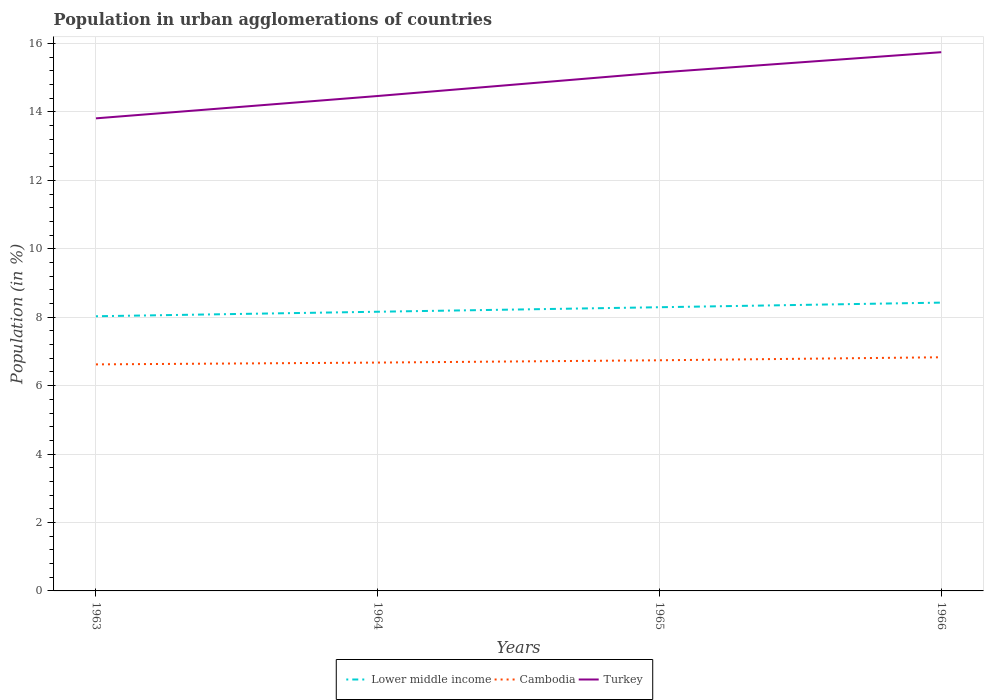How many different coloured lines are there?
Your response must be concise. 3. Is the number of lines equal to the number of legend labels?
Give a very brief answer. Yes. Across all years, what is the maximum percentage of population in urban agglomerations in Cambodia?
Your answer should be compact. 6.62. What is the total percentage of population in urban agglomerations in Turkey in the graph?
Your answer should be compact. -1.34. What is the difference between the highest and the second highest percentage of population in urban agglomerations in Cambodia?
Offer a terse response. 0.21. What is the difference between the highest and the lowest percentage of population in urban agglomerations in Turkey?
Make the answer very short. 2. Is the percentage of population in urban agglomerations in Lower middle income strictly greater than the percentage of population in urban agglomerations in Turkey over the years?
Ensure brevity in your answer.  Yes. Are the values on the major ticks of Y-axis written in scientific E-notation?
Make the answer very short. No. How many legend labels are there?
Your answer should be very brief. 3. What is the title of the graph?
Your answer should be compact. Population in urban agglomerations of countries. What is the label or title of the X-axis?
Keep it short and to the point. Years. What is the Population (in %) of Lower middle income in 1963?
Provide a short and direct response. 8.03. What is the Population (in %) in Cambodia in 1963?
Your answer should be very brief. 6.62. What is the Population (in %) of Turkey in 1963?
Your answer should be very brief. 13.81. What is the Population (in %) in Lower middle income in 1964?
Your response must be concise. 8.16. What is the Population (in %) in Cambodia in 1964?
Provide a short and direct response. 6.67. What is the Population (in %) in Turkey in 1964?
Keep it short and to the point. 14.47. What is the Population (in %) in Lower middle income in 1965?
Your answer should be very brief. 8.29. What is the Population (in %) in Cambodia in 1965?
Ensure brevity in your answer.  6.74. What is the Population (in %) of Turkey in 1965?
Provide a short and direct response. 15.15. What is the Population (in %) of Lower middle income in 1966?
Your answer should be compact. 8.43. What is the Population (in %) of Cambodia in 1966?
Offer a very short reply. 6.83. What is the Population (in %) in Turkey in 1966?
Provide a short and direct response. 15.75. Across all years, what is the maximum Population (in %) in Lower middle income?
Your response must be concise. 8.43. Across all years, what is the maximum Population (in %) in Cambodia?
Ensure brevity in your answer.  6.83. Across all years, what is the maximum Population (in %) in Turkey?
Provide a short and direct response. 15.75. Across all years, what is the minimum Population (in %) of Lower middle income?
Make the answer very short. 8.03. Across all years, what is the minimum Population (in %) in Cambodia?
Provide a succinct answer. 6.62. Across all years, what is the minimum Population (in %) in Turkey?
Ensure brevity in your answer.  13.81. What is the total Population (in %) of Lower middle income in the graph?
Your response must be concise. 32.91. What is the total Population (in %) in Cambodia in the graph?
Provide a succinct answer. 26.87. What is the total Population (in %) in Turkey in the graph?
Offer a very short reply. 59.18. What is the difference between the Population (in %) in Lower middle income in 1963 and that in 1964?
Give a very brief answer. -0.13. What is the difference between the Population (in %) in Cambodia in 1963 and that in 1964?
Keep it short and to the point. -0.05. What is the difference between the Population (in %) in Turkey in 1963 and that in 1964?
Offer a terse response. -0.65. What is the difference between the Population (in %) in Lower middle income in 1963 and that in 1965?
Offer a terse response. -0.26. What is the difference between the Population (in %) in Cambodia in 1963 and that in 1965?
Offer a very short reply. -0.12. What is the difference between the Population (in %) of Turkey in 1963 and that in 1965?
Offer a terse response. -1.34. What is the difference between the Population (in %) in Lower middle income in 1963 and that in 1966?
Offer a very short reply. -0.4. What is the difference between the Population (in %) of Cambodia in 1963 and that in 1966?
Your answer should be compact. -0.21. What is the difference between the Population (in %) of Turkey in 1963 and that in 1966?
Your response must be concise. -1.93. What is the difference between the Population (in %) of Lower middle income in 1964 and that in 1965?
Your answer should be compact. -0.13. What is the difference between the Population (in %) in Cambodia in 1964 and that in 1965?
Offer a very short reply. -0.07. What is the difference between the Population (in %) of Turkey in 1964 and that in 1965?
Offer a terse response. -0.69. What is the difference between the Population (in %) in Lower middle income in 1964 and that in 1966?
Give a very brief answer. -0.27. What is the difference between the Population (in %) of Cambodia in 1964 and that in 1966?
Provide a succinct answer. -0.16. What is the difference between the Population (in %) in Turkey in 1964 and that in 1966?
Give a very brief answer. -1.28. What is the difference between the Population (in %) in Lower middle income in 1965 and that in 1966?
Give a very brief answer. -0.13. What is the difference between the Population (in %) of Cambodia in 1965 and that in 1966?
Provide a short and direct response. -0.09. What is the difference between the Population (in %) of Turkey in 1965 and that in 1966?
Provide a short and direct response. -0.59. What is the difference between the Population (in %) in Lower middle income in 1963 and the Population (in %) in Cambodia in 1964?
Provide a succinct answer. 1.35. What is the difference between the Population (in %) in Lower middle income in 1963 and the Population (in %) in Turkey in 1964?
Offer a terse response. -6.44. What is the difference between the Population (in %) of Cambodia in 1963 and the Population (in %) of Turkey in 1964?
Offer a very short reply. -7.84. What is the difference between the Population (in %) in Lower middle income in 1963 and the Population (in %) in Cambodia in 1965?
Offer a terse response. 1.29. What is the difference between the Population (in %) of Lower middle income in 1963 and the Population (in %) of Turkey in 1965?
Ensure brevity in your answer.  -7.12. What is the difference between the Population (in %) of Cambodia in 1963 and the Population (in %) of Turkey in 1965?
Offer a terse response. -8.53. What is the difference between the Population (in %) of Lower middle income in 1963 and the Population (in %) of Cambodia in 1966?
Your response must be concise. 1.2. What is the difference between the Population (in %) in Lower middle income in 1963 and the Population (in %) in Turkey in 1966?
Offer a very short reply. -7.72. What is the difference between the Population (in %) in Cambodia in 1963 and the Population (in %) in Turkey in 1966?
Offer a very short reply. -9.13. What is the difference between the Population (in %) of Lower middle income in 1964 and the Population (in %) of Cambodia in 1965?
Make the answer very short. 1.42. What is the difference between the Population (in %) in Lower middle income in 1964 and the Population (in %) in Turkey in 1965?
Your response must be concise. -6.99. What is the difference between the Population (in %) of Cambodia in 1964 and the Population (in %) of Turkey in 1965?
Keep it short and to the point. -8.48. What is the difference between the Population (in %) in Lower middle income in 1964 and the Population (in %) in Cambodia in 1966?
Offer a terse response. 1.33. What is the difference between the Population (in %) of Lower middle income in 1964 and the Population (in %) of Turkey in 1966?
Your answer should be compact. -7.59. What is the difference between the Population (in %) of Cambodia in 1964 and the Population (in %) of Turkey in 1966?
Offer a very short reply. -9.07. What is the difference between the Population (in %) in Lower middle income in 1965 and the Population (in %) in Cambodia in 1966?
Offer a very short reply. 1.46. What is the difference between the Population (in %) in Lower middle income in 1965 and the Population (in %) in Turkey in 1966?
Provide a succinct answer. -7.45. What is the difference between the Population (in %) in Cambodia in 1965 and the Population (in %) in Turkey in 1966?
Your answer should be very brief. -9.01. What is the average Population (in %) of Lower middle income per year?
Keep it short and to the point. 8.23. What is the average Population (in %) of Cambodia per year?
Keep it short and to the point. 6.72. What is the average Population (in %) in Turkey per year?
Provide a succinct answer. 14.8. In the year 1963, what is the difference between the Population (in %) in Lower middle income and Population (in %) in Cambodia?
Provide a short and direct response. 1.41. In the year 1963, what is the difference between the Population (in %) of Lower middle income and Population (in %) of Turkey?
Give a very brief answer. -5.78. In the year 1963, what is the difference between the Population (in %) in Cambodia and Population (in %) in Turkey?
Provide a succinct answer. -7.19. In the year 1964, what is the difference between the Population (in %) of Lower middle income and Population (in %) of Cambodia?
Ensure brevity in your answer.  1.49. In the year 1964, what is the difference between the Population (in %) in Lower middle income and Population (in %) in Turkey?
Offer a very short reply. -6.31. In the year 1964, what is the difference between the Population (in %) in Cambodia and Population (in %) in Turkey?
Offer a very short reply. -7.79. In the year 1965, what is the difference between the Population (in %) of Lower middle income and Population (in %) of Cambodia?
Keep it short and to the point. 1.55. In the year 1965, what is the difference between the Population (in %) in Lower middle income and Population (in %) in Turkey?
Give a very brief answer. -6.86. In the year 1965, what is the difference between the Population (in %) of Cambodia and Population (in %) of Turkey?
Keep it short and to the point. -8.41. In the year 1966, what is the difference between the Population (in %) in Lower middle income and Population (in %) in Cambodia?
Ensure brevity in your answer.  1.6. In the year 1966, what is the difference between the Population (in %) in Lower middle income and Population (in %) in Turkey?
Offer a very short reply. -7.32. In the year 1966, what is the difference between the Population (in %) in Cambodia and Population (in %) in Turkey?
Your answer should be very brief. -8.92. What is the ratio of the Population (in %) in Lower middle income in 1963 to that in 1964?
Provide a short and direct response. 0.98. What is the ratio of the Population (in %) of Cambodia in 1963 to that in 1964?
Give a very brief answer. 0.99. What is the ratio of the Population (in %) of Turkey in 1963 to that in 1964?
Ensure brevity in your answer.  0.95. What is the ratio of the Population (in %) of Lower middle income in 1963 to that in 1965?
Keep it short and to the point. 0.97. What is the ratio of the Population (in %) in Cambodia in 1963 to that in 1965?
Your answer should be very brief. 0.98. What is the ratio of the Population (in %) in Turkey in 1963 to that in 1965?
Offer a very short reply. 0.91. What is the ratio of the Population (in %) in Lower middle income in 1963 to that in 1966?
Your answer should be very brief. 0.95. What is the ratio of the Population (in %) in Cambodia in 1963 to that in 1966?
Your answer should be very brief. 0.97. What is the ratio of the Population (in %) in Turkey in 1963 to that in 1966?
Provide a succinct answer. 0.88. What is the ratio of the Population (in %) in Lower middle income in 1964 to that in 1965?
Offer a very short reply. 0.98. What is the ratio of the Population (in %) in Turkey in 1964 to that in 1965?
Your response must be concise. 0.95. What is the ratio of the Population (in %) in Lower middle income in 1964 to that in 1966?
Your answer should be compact. 0.97. What is the ratio of the Population (in %) in Cambodia in 1964 to that in 1966?
Offer a terse response. 0.98. What is the ratio of the Population (in %) in Turkey in 1964 to that in 1966?
Ensure brevity in your answer.  0.92. What is the ratio of the Population (in %) of Cambodia in 1965 to that in 1966?
Provide a succinct answer. 0.99. What is the ratio of the Population (in %) in Turkey in 1965 to that in 1966?
Your response must be concise. 0.96. What is the difference between the highest and the second highest Population (in %) in Lower middle income?
Offer a terse response. 0.13. What is the difference between the highest and the second highest Population (in %) in Cambodia?
Provide a succinct answer. 0.09. What is the difference between the highest and the second highest Population (in %) in Turkey?
Ensure brevity in your answer.  0.59. What is the difference between the highest and the lowest Population (in %) in Lower middle income?
Make the answer very short. 0.4. What is the difference between the highest and the lowest Population (in %) in Cambodia?
Ensure brevity in your answer.  0.21. What is the difference between the highest and the lowest Population (in %) in Turkey?
Offer a very short reply. 1.93. 